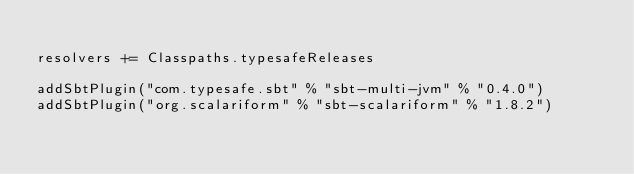<code> <loc_0><loc_0><loc_500><loc_500><_Scala_>
resolvers += Classpaths.typesafeReleases

addSbtPlugin("com.typesafe.sbt" % "sbt-multi-jvm" % "0.4.0")
addSbtPlugin("org.scalariform" % "sbt-scalariform" % "1.8.2")</code> 